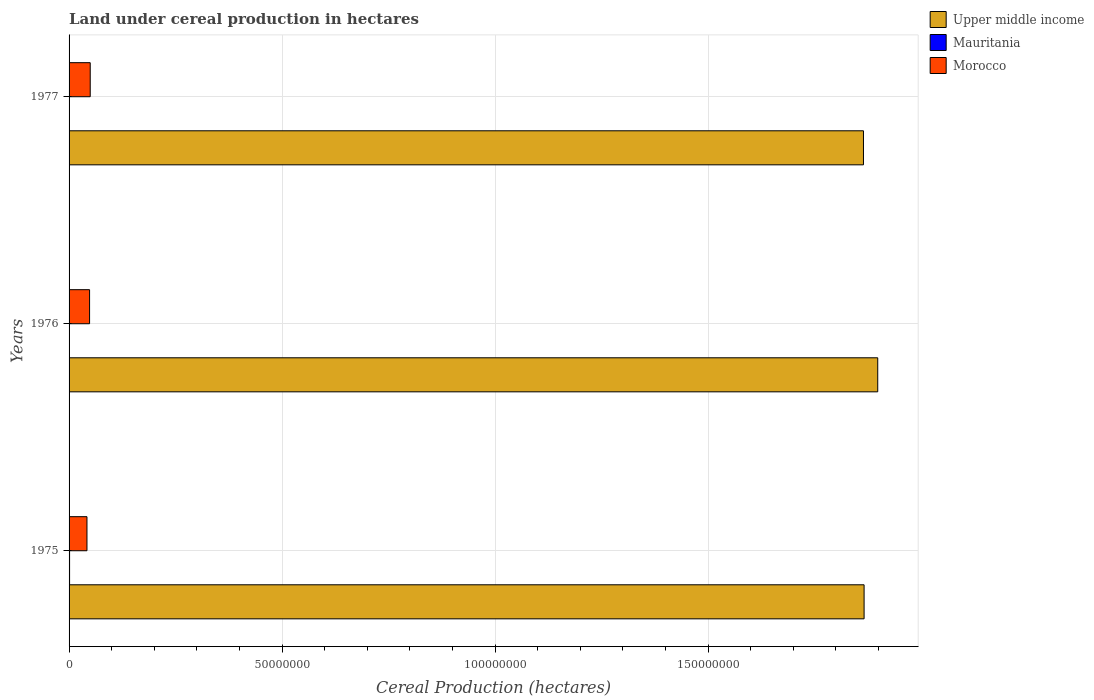How many different coloured bars are there?
Provide a short and direct response. 3. How many groups of bars are there?
Your answer should be compact. 3. Are the number of bars per tick equal to the number of legend labels?
Keep it short and to the point. Yes. Are the number of bars on each tick of the Y-axis equal?
Keep it short and to the point. Yes. How many bars are there on the 3rd tick from the bottom?
Your answer should be compact. 3. In how many cases, is the number of bars for a given year not equal to the number of legend labels?
Ensure brevity in your answer.  0. What is the land under cereal production in Morocco in 1977?
Offer a very short reply. 4.96e+06. Across all years, what is the maximum land under cereal production in Upper middle income?
Your answer should be compact. 1.90e+08. Across all years, what is the minimum land under cereal production in Upper middle income?
Your answer should be compact. 1.86e+08. In which year was the land under cereal production in Upper middle income maximum?
Offer a terse response. 1976. What is the total land under cereal production in Morocco in the graph?
Offer a very short reply. 1.40e+07. What is the difference between the land under cereal production in Mauritania in 1975 and that in 1976?
Offer a very short reply. 3.82e+04. What is the difference between the land under cereal production in Mauritania in 1977 and the land under cereal production in Morocco in 1976?
Make the answer very short. -4.74e+06. What is the average land under cereal production in Mauritania per year?
Keep it short and to the point. 8.97e+04. In the year 1975, what is the difference between the land under cereal production in Morocco and land under cereal production in Upper middle income?
Your answer should be compact. -1.82e+08. In how many years, is the land under cereal production in Mauritania greater than 150000000 hectares?
Your answer should be compact. 0. What is the ratio of the land under cereal production in Morocco in 1975 to that in 1976?
Your answer should be very brief. 0.87. Is the land under cereal production in Mauritania in 1976 less than that in 1977?
Offer a terse response. No. What is the difference between the highest and the second highest land under cereal production in Upper middle income?
Make the answer very short. 3.20e+06. What is the difference between the highest and the lowest land under cereal production in Morocco?
Keep it short and to the point. 7.63e+05. Is the sum of the land under cereal production in Mauritania in 1975 and 1977 greater than the maximum land under cereal production in Upper middle income across all years?
Your answer should be compact. No. What does the 3rd bar from the top in 1976 represents?
Keep it short and to the point. Upper middle income. What does the 2nd bar from the bottom in 1976 represents?
Your answer should be compact. Mauritania. Are all the bars in the graph horizontal?
Your response must be concise. Yes. How are the legend labels stacked?
Your answer should be compact. Vertical. What is the title of the graph?
Offer a very short reply. Land under cereal production in hectares. What is the label or title of the X-axis?
Ensure brevity in your answer.  Cereal Production (hectares). What is the label or title of the Y-axis?
Provide a short and direct response. Years. What is the Cereal Production (hectares) of Upper middle income in 1975?
Provide a succinct answer. 1.87e+08. What is the Cereal Production (hectares) in Mauritania in 1975?
Ensure brevity in your answer.  1.19e+05. What is the Cereal Production (hectares) of Morocco in 1975?
Offer a very short reply. 4.20e+06. What is the Cereal Production (hectares) of Upper middle income in 1976?
Offer a terse response. 1.90e+08. What is the Cereal Production (hectares) in Mauritania in 1976?
Ensure brevity in your answer.  8.03e+04. What is the Cereal Production (hectares) in Morocco in 1976?
Your response must be concise. 4.81e+06. What is the Cereal Production (hectares) in Upper middle income in 1977?
Offer a very short reply. 1.86e+08. What is the Cereal Production (hectares) of Mauritania in 1977?
Keep it short and to the point. 7.02e+04. What is the Cereal Production (hectares) of Morocco in 1977?
Make the answer very short. 4.96e+06. Across all years, what is the maximum Cereal Production (hectares) in Upper middle income?
Make the answer very short. 1.90e+08. Across all years, what is the maximum Cereal Production (hectares) of Mauritania?
Offer a terse response. 1.19e+05. Across all years, what is the maximum Cereal Production (hectares) of Morocco?
Your answer should be compact. 4.96e+06. Across all years, what is the minimum Cereal Production (hectares) in Upper middle income?
Provide a succinct answer. 1.86e+08. Across all years, what is the minimum Cereal Production (hectares) in Mauritania?
Offer a terse response. 7.02e+04. Across all years, what is the minimum Cereal Production (hectares) in Morocco?
Ensure brevity in your answer.  4.20e+06. What is the total Cereal Production (hectares) in Upper middle income in the graph?
Your response must be concise. 5.63e+08. What is the total Cereal Production (hectares) in Mauritania in the graph?
Your answer should be compact. 2.69e+05. What is the total Cereal Production (hectares) in Morocco in the graph?
Provide a succinct answer. 1.40e+07. What is the difference between the Cereal Production (hectares) of Upper middle income in 1975 and that in 1976?
Make the answer very short. -3.20e+06. What is the difference between the Cereal Production (hectares) in Mauritania in 1975 and that in 1976?
Your answer should be compact. 3.82e+04. What is the difference between the Cereal Production (hectares) of Morocco in 1975 and that in 1976?
Provide a short and direct response. -6.12e+05. What is the difference between the Cereal Production (hectares) of Upper middle income in 1975 and that in 1977?
Your answer should be very brief. 1.47e+05. What is the difference between the Cereal Production (hectares) of Mauritania in 1975 and that in 1977?
Provide a short and direct response. 4.83e+04. What is the difference between the Cereal Production (hectares) in Morocco in 1975 and that in 1977?
Keep it short and to the point. -7.63e+05. What is the difference between the Cereal Production (hectares) in Upper middle income in 1976 and that in 1977?
Provide a short and direct response. 3.35e+06. What is the difference between the Cereal Production (hectares) of Mauritania in 1976 and that in 1977?
Your answer should be compact. 1.01e+04. What is the difference between the Cereal Production (hectares) in Morocco in 1976 and that in 1977?
Make the answer very short. -1.51e+05. What is the difference between the Cereal Production (hectares) in Upper middle income in 1975 and the Cereal Production (hectares) in Mauritania in 1976?
Make the answer very short. 1.87e+08. What is the difference between the Cereal Production (hectares) of Upper middle income in 1975 and the Cereal Production (hectares) of Morocco in 1976?
Offer a very short reply. 1.82e+08. What is the difference between the Cereal Production (hectares) of Mauritania in 1975 and the Cereal Production (hectares) of Morocco in 1976?
Make the answer very short. -4.69e+06. What is the difference between the Cereal Production (hectares) in Upper middle income in 1975 and the Cereal Production (hectares) in Mauritania in 1977?
Your answer should be very brief. 1.87e+08. What is the difference between the Cereal Production (hectares) in Upper middle income in 1975 and the Cereal Production (hectares) in Morocco in 1977?
Give a very brief answer. 1.82e+08. What is the difference between the Cereal Production (hectares) in Mauritania in 1975 and the Cereal Production (hectares) in Morocco in 1977?
Your response must be concise. -4.84e+06. What is the difference between the Cereal Production (hectares) of Upper middle income in 1976 and the Cereal Production (hectares) of Mauritania in 1977?
Keep it short and to the point. 1.90e+08. What is the difference between the Cereal Production (hectares) in Upper middle income in 1976 and the Cereal Production (hectares) in Morocco in 1977?
Provide a succinct answer. 1.85e+08. What is the difference between the Cereal Production (hectares) of Mauritania in 1976 and the Cereal Production (hectares) of Morocco in 1977?
Your response must be concise. -4.88e+06. What is the average Cereal Production (hectares) of Upper middle income per year?
Provide a short and direct response. 1.88e+08. What is the average Cereal Production (hectares) of Mauritania per year?
Ensure brevity in your answer.  8.97e+04. What is the average Cereal Production (hectares) of Morocco per year?
Offer a very short reply. 4.66e+06. In the year 1975, what is the difference between the Cereal Production (hectares) of Upper middle income and Cereal Production (hectares) of Mauritania?
Your answer should be compact. 1.86e+08. In the year 1975, what is the difference between the Cereal Production (hectares) of Upper middle income and Cereal Production (hectares) of Morocco?
Your response must be concise. 1.82e+08. In the year 1975, what is the difference between the Cereal Production (hectares) in Mauritania and Cereal Production (hectares) in Morocco?
Make the answer very short. -4.08e+06. In the year 1976, what is the difference between the Cereal Production (hectares) in Upper middle income and Cereal Production (hectares) in Mauritania?
Keep it short and to the point. 1.90e+08. In the year 1976, what is the difference between the Cereal Production (hectares) of Upper middle income and Cereal Production (hectares) of Morocco?
Offer a very short reply. 1.85e+08. In the year 1976, what is the difference between the Cereal Production (hectares) of Mauritania and Cereal Production (hectares) of Morocco?
Your response must be concise. -4.73e+06. In the year 1977, what is the difference between the Cereal Production (hectares) of Upper middle income and Cereal Production (hectares) of Mauritania?
Ensure brevity in your answer.  1.86e+08. In the year 1977, what is the difference between the Cereal Production (hectares) of Upper middle income and Cereal Production (hectares) of Morocco?
Your answer should be very brief. 1.82e+08. In the year 1977, what is the difference between the Cereal Production (hectares) in Mauritania and Cereal Production (hectares) in Morocco?
Your answer should be very brief. -4.89e+06. What is the ratio of the Cereal Production (hectares) of Upper middle income in 1975 to that in 1976?
Offer a terse response. 0.98. What is the ratio of the Cereal Production (hectares) of Mauritania in 1975 to that in 1976?
Offer a terse response. 1.48. What is the ratio of the Cereal Production (hectares) in Morocco in 1975 to that in 1976?
Your answer should be compact. 0.87. What is the ratio of the Cereal Production (hectares) of Mauritania in 1975 to that in 1977?
Offer a very short reply. 1.69. What is the ratio of the Cereal Production (hectares) of Morocco in 1975 to that in 1977?
Ensure brevity in your answer.  0.85. What is the ratio of the Cereal Production (hectares) of Upper middle income in 1976 to that in 1977?
Provide a short and direct response. 1.02. What is the ratio of the Cereal Production (hectares) of Mauritania in 1976 to that in 1977?
Offer a very short reply. 1.14. What is the ratio of the Cereal Production (hectares) of Morocco in 1976 to that in 1977?
Make the answer very short. 0.97. What is the difference between the highest and the second highest Cereal Production (hectares) in Upper middle income?
Ensure brevity in your answer.  3.20e+06. What is the difference between the highest and the second highest Cereal Production (hectares) in Mauritania?
Make the answer very short. 3.82e+04. What is the difference between the highest and the second highest Cereal Production (hectares) in Morocco?
Ensure brevity in your answer.  1.51e+05. What is the difference between the highest and the lowest Cereal Production (hectares) of Upper middle income?
Ensure brevity in your answer.  3.35e+06. What is the difference between the highest and the lowest Cereal Production (hectares) in Mauritania?
Offer a very short reply. 4.83e+04. What is the difference between the highest and the lowest Cereal Production (hectares) of Morocco?
Make the answer very short. 7.63e+05. 